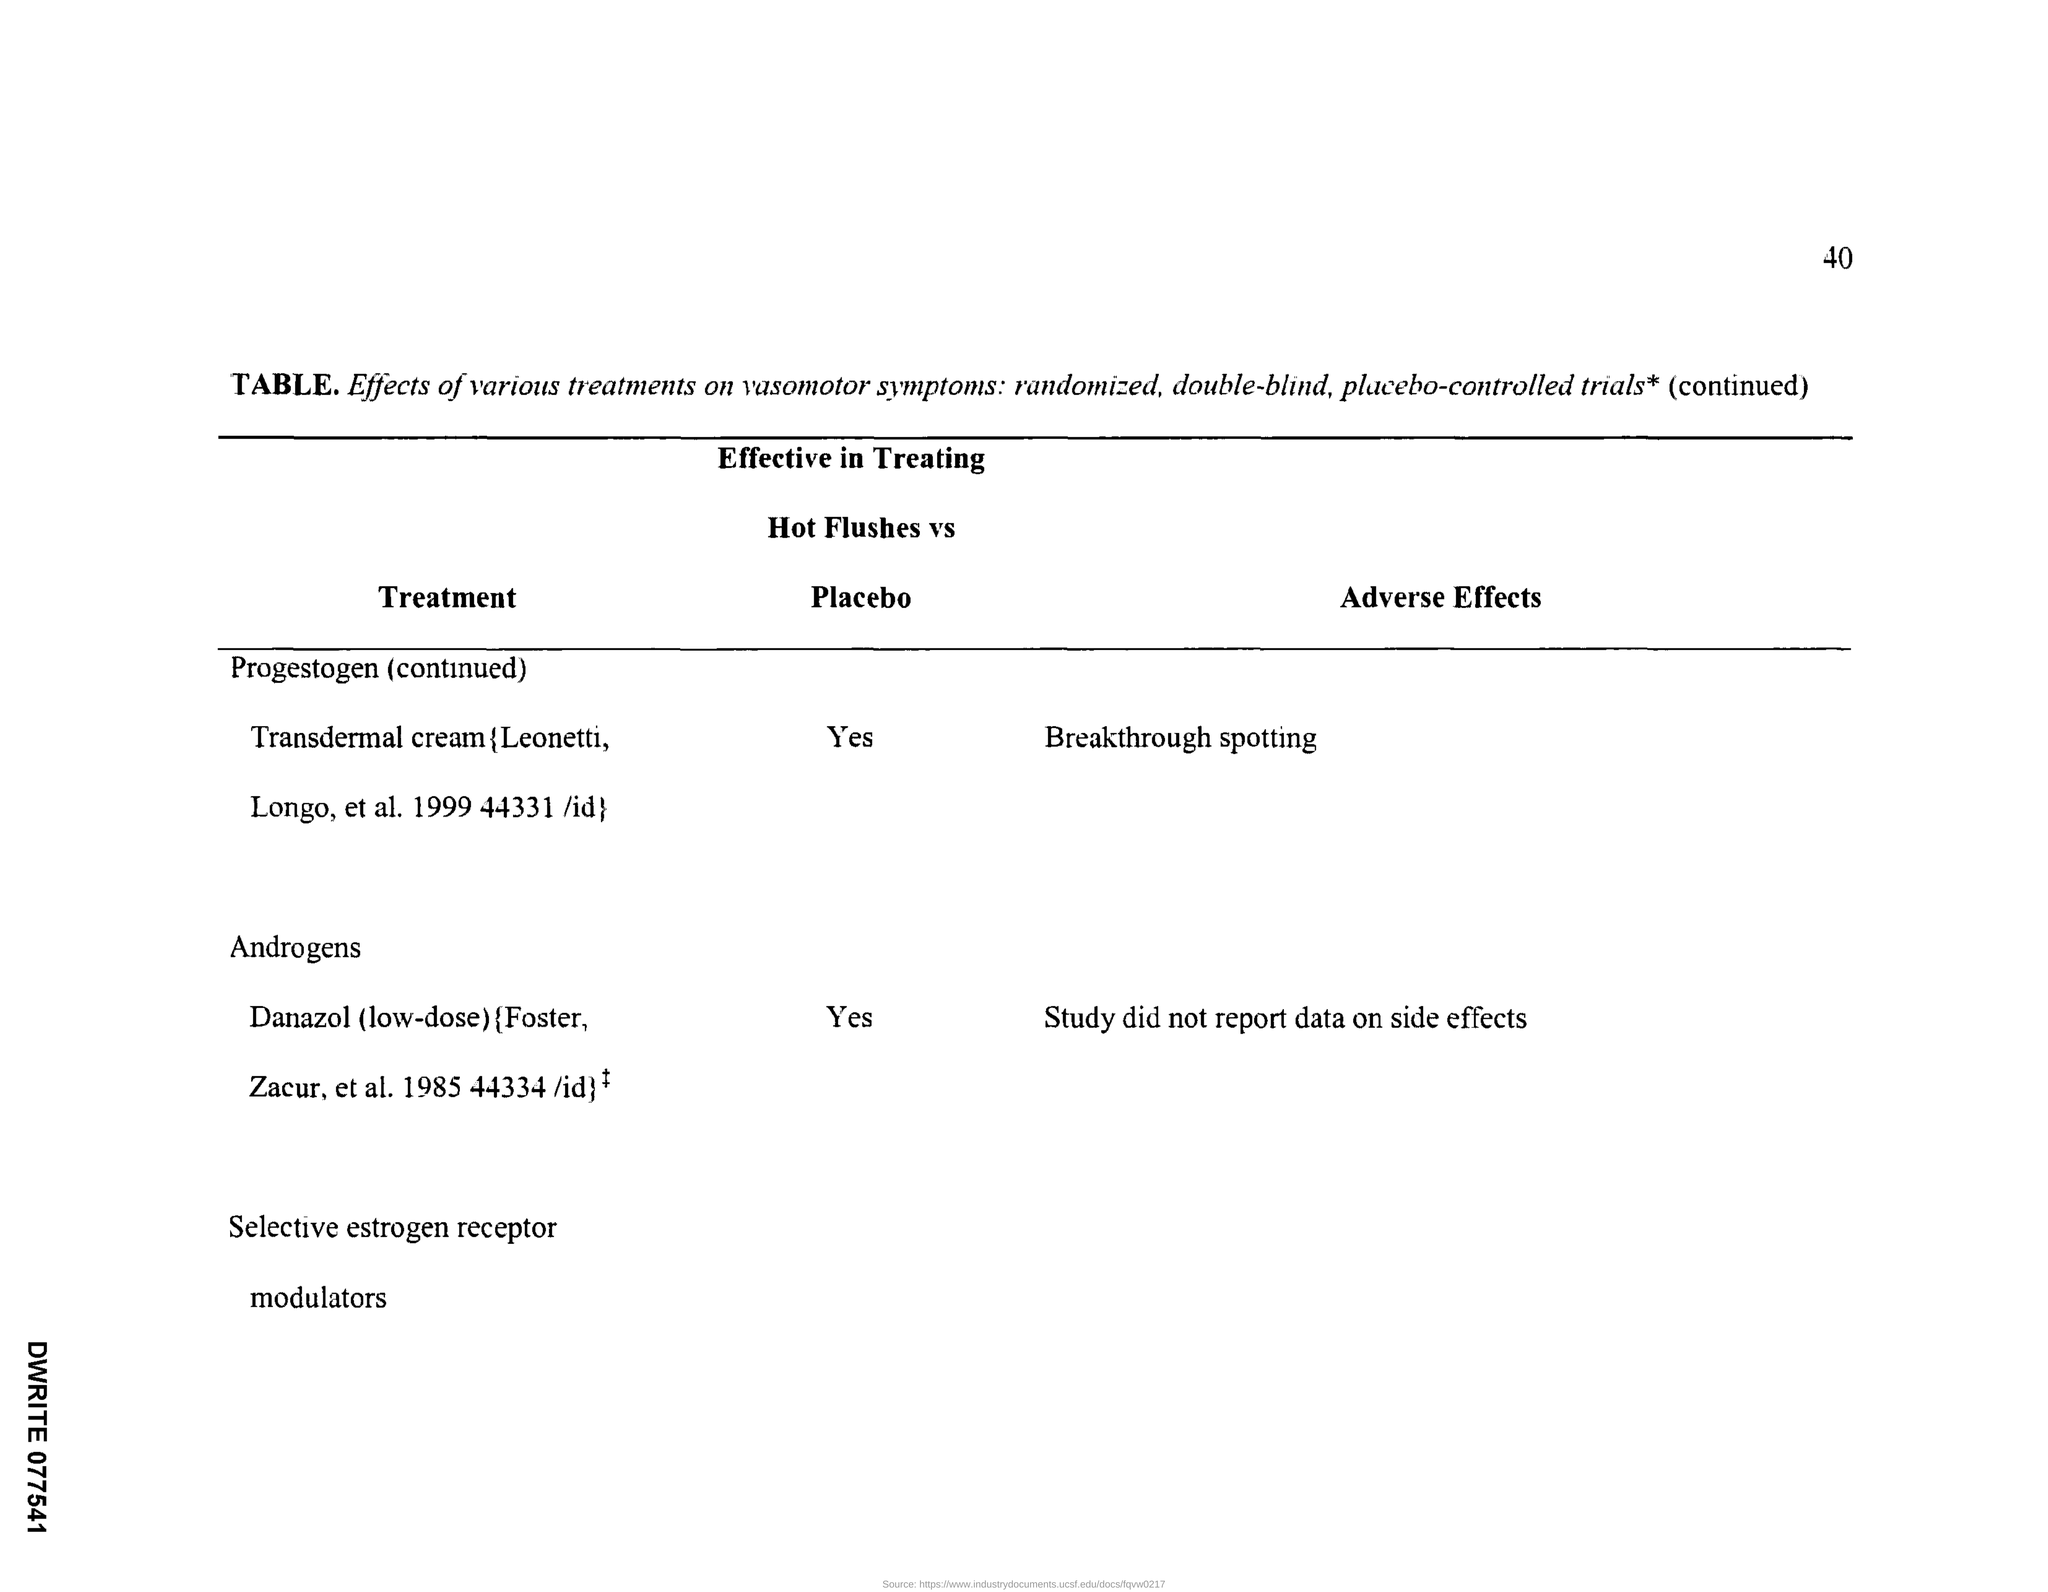What is the Page number given at the top right corner of the page?
Your answer should be compact. 40. "Effects of various treatments on" which symptoms are mentioned here?
Keep it short and to the point. Vasomotor. What is the heading given to the first column of the "Table"?
Offer a terse response. Treatment. What is the heading given to the second column of the "Table"?
Provide a succinct answer. Effective in treating Hot Flushes vs Placebo. What is the heading given to the third column of the "Table"?
Make the answer very short. Adverse Effects. What is the "Adverse Effects" of "Progestogen (continued)" Treatment?
Keep it short and to the point. Breakthrough spotting. What is the "Adverse Effects" of "Androgens" Treatment?
Offer a very short reply. Study did not report data on side effects. Is "Progestogen (continued)" Treatment "Effective in treating Hot Flushes vs Placebo"?
Your answer should be very brief. Yes. Is "Androgens" Treatment "Effective in treating Hot Flushes vs Placebo"?
Provide a succinct answer. Yes. 